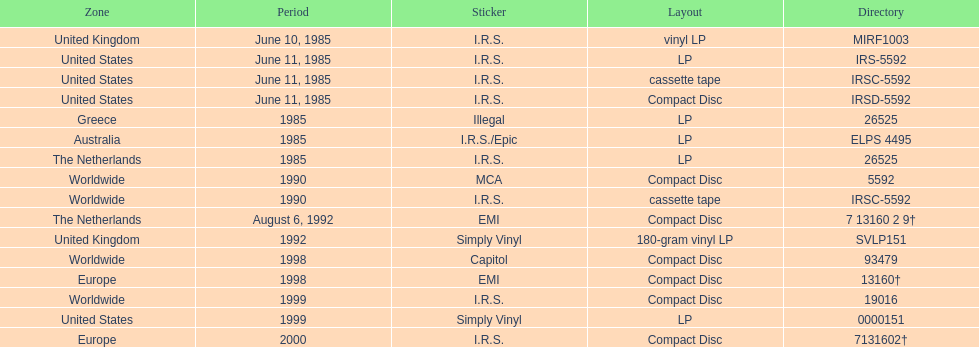Which is the only region with vinyl lp format? United Kingdom. 